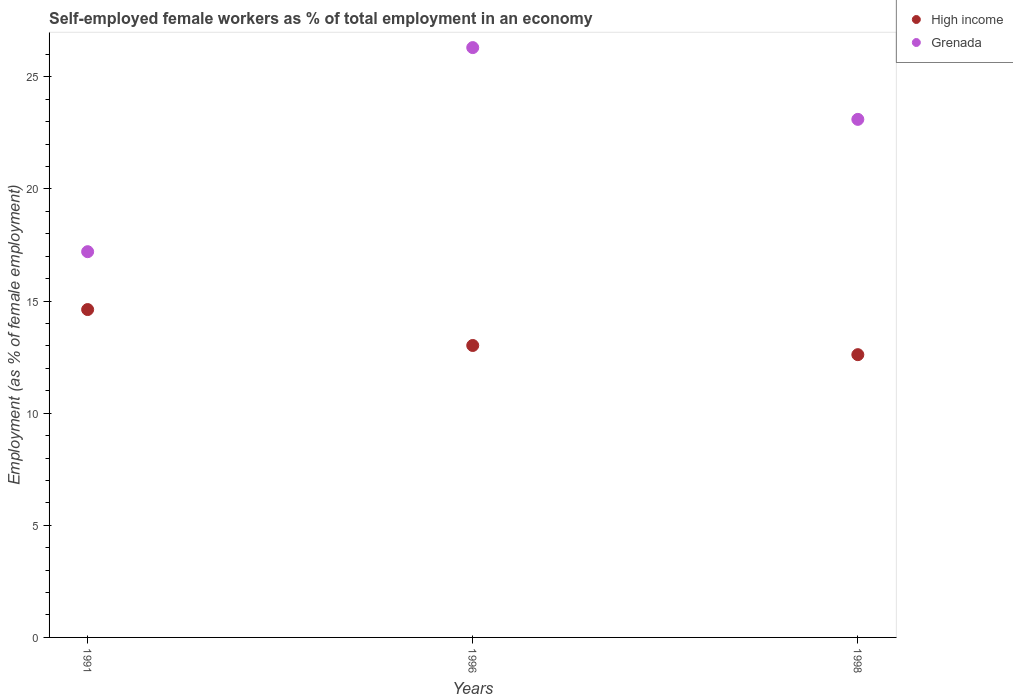Is the number of dotlines equal to the number of legend labels?
Make the answer very short. Yes. What is the percentage of self-employed female workers in High income in 1998?
Make the answer very short. 12.61. Across all years, what is the maximum percentage of self-employed female workers in Grenada?
Offer a very short reply. 26.3. Across all years, what is the minimum percentage of self-employed female workers in Grenada?
Ensure brevity in your answer.  17.2. What is the total percentage of self-employed female workers in High income in the graph?
Provide a short and direct response. 40.25. What is the difference between the percentage of self-employed female workers in Grenada in 1991 and that in 1998?
Your answer should be compact. -5.9. What is the difference between the percentage of self-employed female workers in Grenada in 1991 and the percentage of self-employed female workers in High income in 1996?
Offer a terse response. 4.18. What is the average percentage of self-employed female workers in High income per year?
Your answer should be very brief. 13.42. In the year 1998, what is the difference between the percentage of self-employed female workers in Grenada and percentage of self-employed female workers in High income?
Give a very brief answer. 10.49. In how many years, is the percentage of self-employed female workers in High income greater than 13 %?
Provide a short and direct response. 2. What is the ratio of the percentage of self-employed female workers in Grenada in 1991 to that in 1996?
Provide a short and direct response. 0.65. What is the difference between the highest and the second highest percentage of self-employed female workers in Grenada?
Your response must be concise. 3.2. What is the difference between the highest and the lowest percentage of self-employed female workers in Grenada?
Your response must be concise. 9.1. In how many years, is the percentage of self-employed female workers in Grenada greater than the average percentage of self-employed female workers in Grenada taken over all years?
Provide a succinct answer. 2. Does the percentage of self-employed female workers in High income monotonically increase over the years?
Your response must be concise. No. Is the percentage of self-employed female workers in Grenada strictly greater than the percentage of self-employed female workers in High income over the years?
Your answer should be very brief. Yes. Is the percentage of self-employed female workers in Grenada strictly less than the percentage of self-employed female workers in High income over the years?
Keep it short and to the point. No. How many years are there in the graph?
Provide a succinct answer. 3. Does the graph contain any zero values?
Offer a very short reply. No. Does the graph contain grids?
Keep it short and to the point. No. How many legend labels are there?
Provide a succinct answer. 2. What is the title of the graph?
Provide a succinct answer. Self-employed female workers as % of total employment in an economy. What is the label or title of the X-axis?
Your answer should be very brief. Years. What is the label or title of the Y-axis?
Keep it short and to the point. Employment (as % of female employment). What is the Employment (as % of female employment) of High income in 1991?
Your answer should be very brief. 14.62. What is the Employment (as % of female employment) of Grenada in 1991?
Offer a terse response. 17.2. What is the Employment (as % of female employment) of High income in 1996?
Ensure brevity in your answer.  13.02. What is the Employment (as % of female employment) in Grenada in 1996?
Your answer should be very brief. 26.3. What is the Employment (as % of female employment) in High income in 1998?
Make the answer very short. 12.61. What is the Employment (as % of female employment) of Grenada in 1998?
Your answer should be very brief. 23.1. Across all years, what is the maximum Employment (as % of female employment) of High income?
Make the answer very short. 14.62. Across all years, what is the maximum Employment (as % of female employment) of Grenada?
Keep it short and to the point. 26.3. Across all years, what is the minimum Employment (as % of female employment) in High income?
Provide a short and direct response. 12.61. Across all years, what is the minimum Employment (as % of female employment) of Grenada?
Ensure brevity in your answer.  17.2. What is the total Employment (as % of female employment) in High income in the graph?
Offer a very short reply. 40.25. What is the total Employment (as % of female employment) of Grenada in the graph?
Provide a succinct answer. 66.6. What is the difference between the Employment (as % of female employment) of High income in 1991 and that in 1996?
Provide a succinct answer. 1.6. What is the difference between the Employment (as % of female employment) in Grenada in 1991 and that in 1996?
Your response must be concise. -9.1. What is the difference between the Employment (as % of female employment) of High income in 1991 and that in 1998?
Provide a succinct answer. 2.01. What is the difference between the Employment (as % of female employment) in High income in 1996 and that in 1998?
Offer a very short reply. 0.41. What is the difference between the Employment (as % of female employment) in Grenada in 1996 and that in 1998?
Your response must be concise. 3.2. What is the difference between the Employment (as % of female employment) in High income in 1991 and the Employment (as % of female employment) in Grenada in 1996?
Provide a short and direct response. -11.68. What is the difference between the Employment (as % of female employment) of High income in 1991 and the Employment (as % of female employment) of Grenada in 1998?
Offer a very short reply. -8.48. What is the difference between the Employment (as % of female employment) in High income in 1996 and the Employment (as % of female employment) in Grenada in 1998?
Give a very brief answer. -10.08. What is the average Employment (as % of female employment) in High income per year?
Provide a short and direct response. 13.42. What is the average Employment (as % of female employment) of Grenada per year?
Keep it short and to the point. 22.2. In the year 1991, what is the difference between the Employment (as % of female employment) in High income and Employment (as % of female employment) in Grenada?
Offer a very short reply. -2.58. In the year 1996, what is the difference between the Employment (as % of female employment) of High income and Employment (as % of female employment) of Grenada?
Make the answer very short. -13.28. In the year 1998, what is the difference between the Employment (as % of female employment) of High income and Employment (as % of female employment) of Grenada?
Offer a terse response. -10.49. What is the ratio of the Employment (as % of female employment) of High income in 1991 to that in 1996?
Offer a terse response. 1.12. What is the ratio of the Employment (as % of female employment) of Grenada in 1991 to that in 1996?
Your response must be concise. 0.65. What is the ratio of the Employment (as % of female employment) in High income in 1991 to that in 1998?
Your answer should be compact. 1.16. What is the ratio of the Employment (as % of female employment) in Grenada in 1991 to that in 1998?
Make the answer very short. 0.74. What is the ratio of the Employment (as % of female employment) of High income in 1996 to that in 1998?
Provide a short and direct response. 1.03. What is the ratio of the Employment (as % of female employment) in Grenada in 1996 to that in 1998?
Ensure brevity in your answer.  1.14. What is the difference between the highest and the second highest Employment (as % of female employment) in High income?
Provide a short and direct response. 1.6. What is the difference between the highest and the lowest Employment (as % of female employment) in High income?
Your answer should be compact. 2.01. What is the difference between the highest and the lowest Employment (as % of female employment) of Grenada?
Make the answer very short. 9.1. 